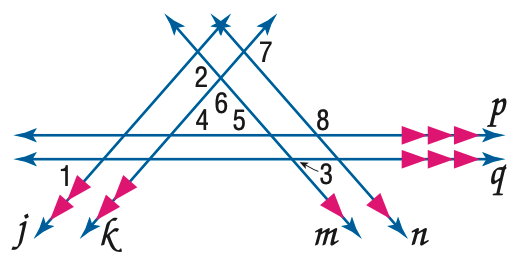Answer the mathemtical geometry problem and directly provide the correct option letter.
Question: In the figure, m \angle 1 = 50 and m \angle 3 = 60. Find the measure of \angle 7.
Choices: A: 110 B: 120 C: 130 D: 140 A 